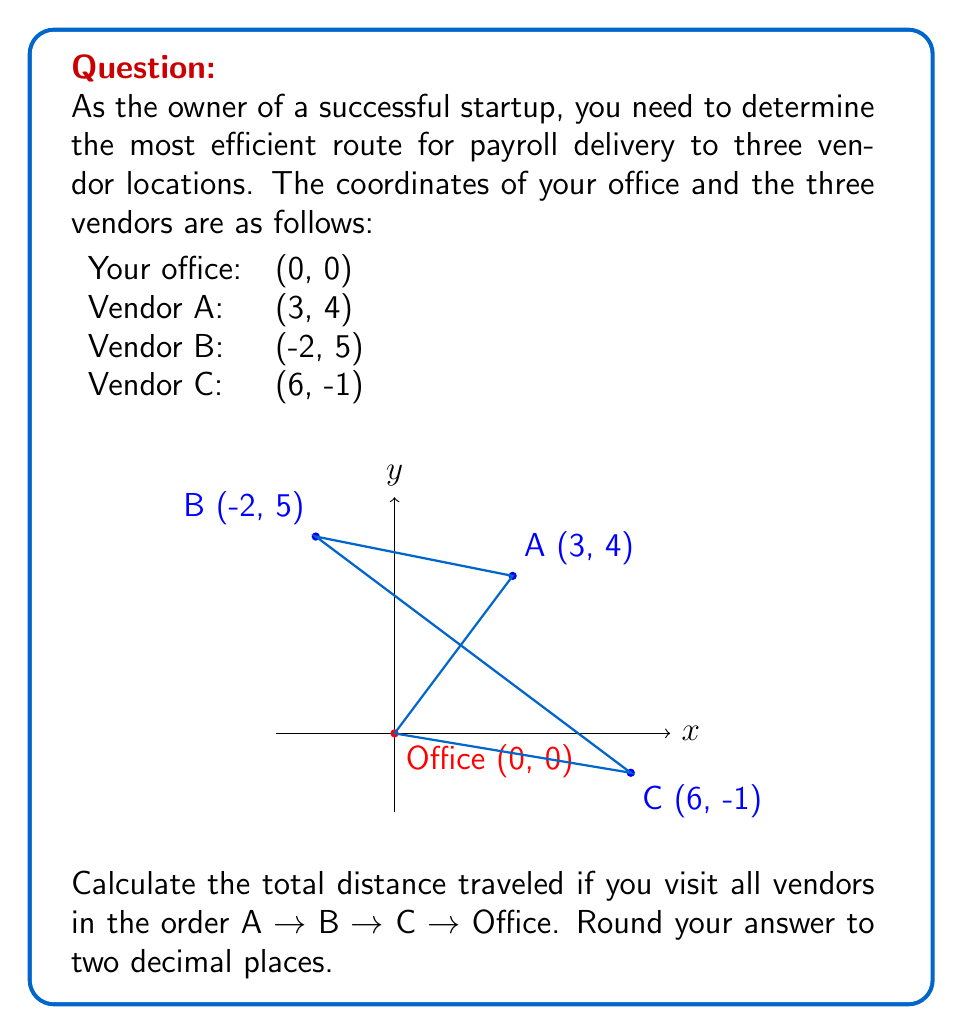Can you answer this question? To solve this problem, we need to calculate the distance between each pair of consecutive points and sum them up. We'll use the distance formula between two points $(x_1, y_1)$ and $(x_2, y_2)$:

$$d = \sqrt{(x_2-x_1)^2 + (y_2-y_1)^2}$$

Step 1: Calculate distance from Office to Vendor A
$$d_{OA} = \sqrt{(3-0)^2 + (4-0)^2} = \sqrt{9 + 16} = \sqrt{25} = 5$$

Step 2: Calculate distance from Vendor A to Vendor B
$$d_{AB} = \sqrt{(-2-3)^2 + (5-4)^2} = \sqrt{(-5)^2 + 1^2} = \sqrt{26}$$

Step 3: Calculate distance from Vendor B to Vendor C
$$d_{BC} = \sqrt{(6-(-2))^2 + (-1-5)^2} = \sqrt{8^2 + (-6)^2} = \sqrt{64 + 36} = \sqrt{100} = 10$$

Step 4: Calculate distance from Vendor C back to Office
$$d_{CO} = \sqrt{(0-6)^2 + (0-(-1))^2} = \sqrt{(-6)^2 + 1^2} = \sqrt{37}$$

Step 5: Sum up all distances
Total distance = $5 + \sqrt{26} + 10 + \sqrt{37}$

Step 6: Evaluate and round to two decimal places
$$5 + \sqrt{26} + 10 + \sqrt{37} \approx 5 + 5.10 + 10 + 6.08 = 26.18$$
Answer: 26.18 units 